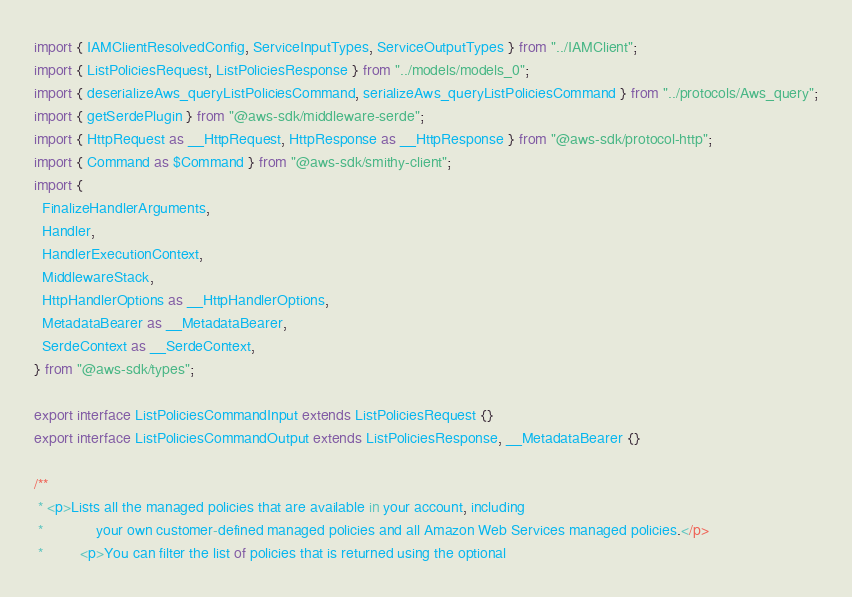<code> <loc_0><loc_0><loc_500><loc_500><_TypeScript_>import { IAMClientResolvedConfig, ServiceInputTypes, ServiceOutputTypes } from "../IAMClient";
import { ListPoliciesRequest, ListPoliciesResponse } from "../models/models_0";
import { deserializeAws_queryListPoliciesCommand, serializeAws_queryListPoliciesCommand } from "../protocols/Aws_query";
import { getSerdePlugin } from "@aws-sdk/middleware-serde";
import { HttpRequest as __HttpRequest, HttpResponse as __HttpResponse } from "@aws-sdk/protocol-http";
import { Command as $Command } from "@aws-sdk/smithy-client";
import {
  FinalizeHandlerArguments,
  Handler,
  HandlerExecutionContext,
  MiddlewareStack,
  HttpHandlerOptions as __HttpHandlerOptions,
  MetadataBearer as __MetadataBearer,
  SerdeContext as __SerdeContext,
} from "@aws-sdk/types";

export interface ListPoliciesCommandInput extends ListPoliciesRequest {}
export interface ListPoliciesCommandOutput extends ListPoliciesResponse, __MetadataBearer {}

/**
 * <p>Lists all the managed policies that are available in your account, including
 *             your own customer-defined managed policies and all Amazon Web Services managed policies.</p>
 *         <p>You can filter the list of policies that is returned using the optional</code> 